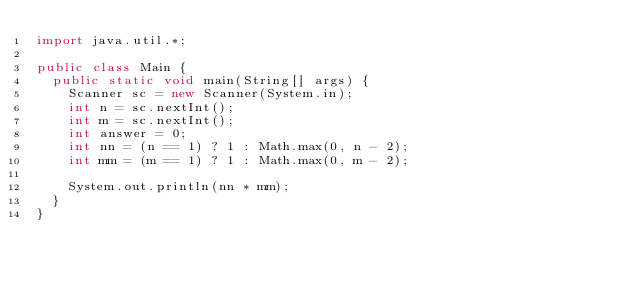Convert code to text. <code><loc_0><loc_0><loc_500><loc_500><_Java_>import java.util.*;

public class Main {
	public static void main(String[] args) {
		Scanner sc = new Scanner(System.in);
		int n = sc.nextInt();
		int m = sc.nextInt();
		int answer = 0;
		int nn = (n == 1) ? 1 : Math.max(0, n - 2);
		int mm = (m == 1) ? 1 : Math.max(0, m - 2);

		System.out.println(nn * mm);
	}
}
</code> 